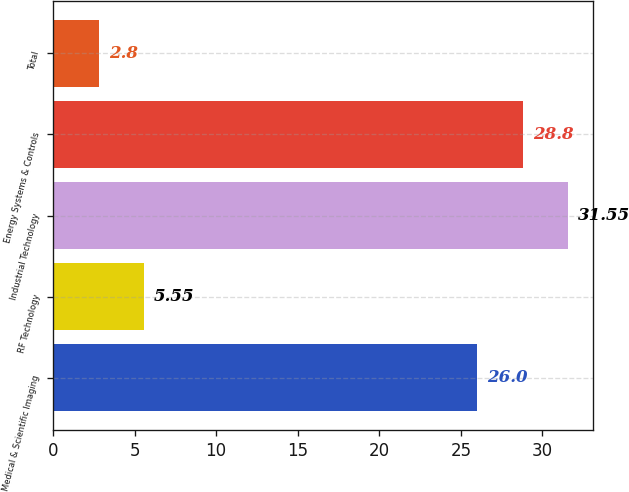Convert chart. <chart><loc_0><loc_0><loc_500><loc_500><bar_chart><fcel>Medical & Scientific Imaging<fcel>RF Technology<fcel>Industrial Technology<fcel>Energy Systems & Controls<fcel>Total<nl><fcel>26<fcel>5.55<fcel>31.55<fcel>28.8<fcel>2.8<nl></chart> 